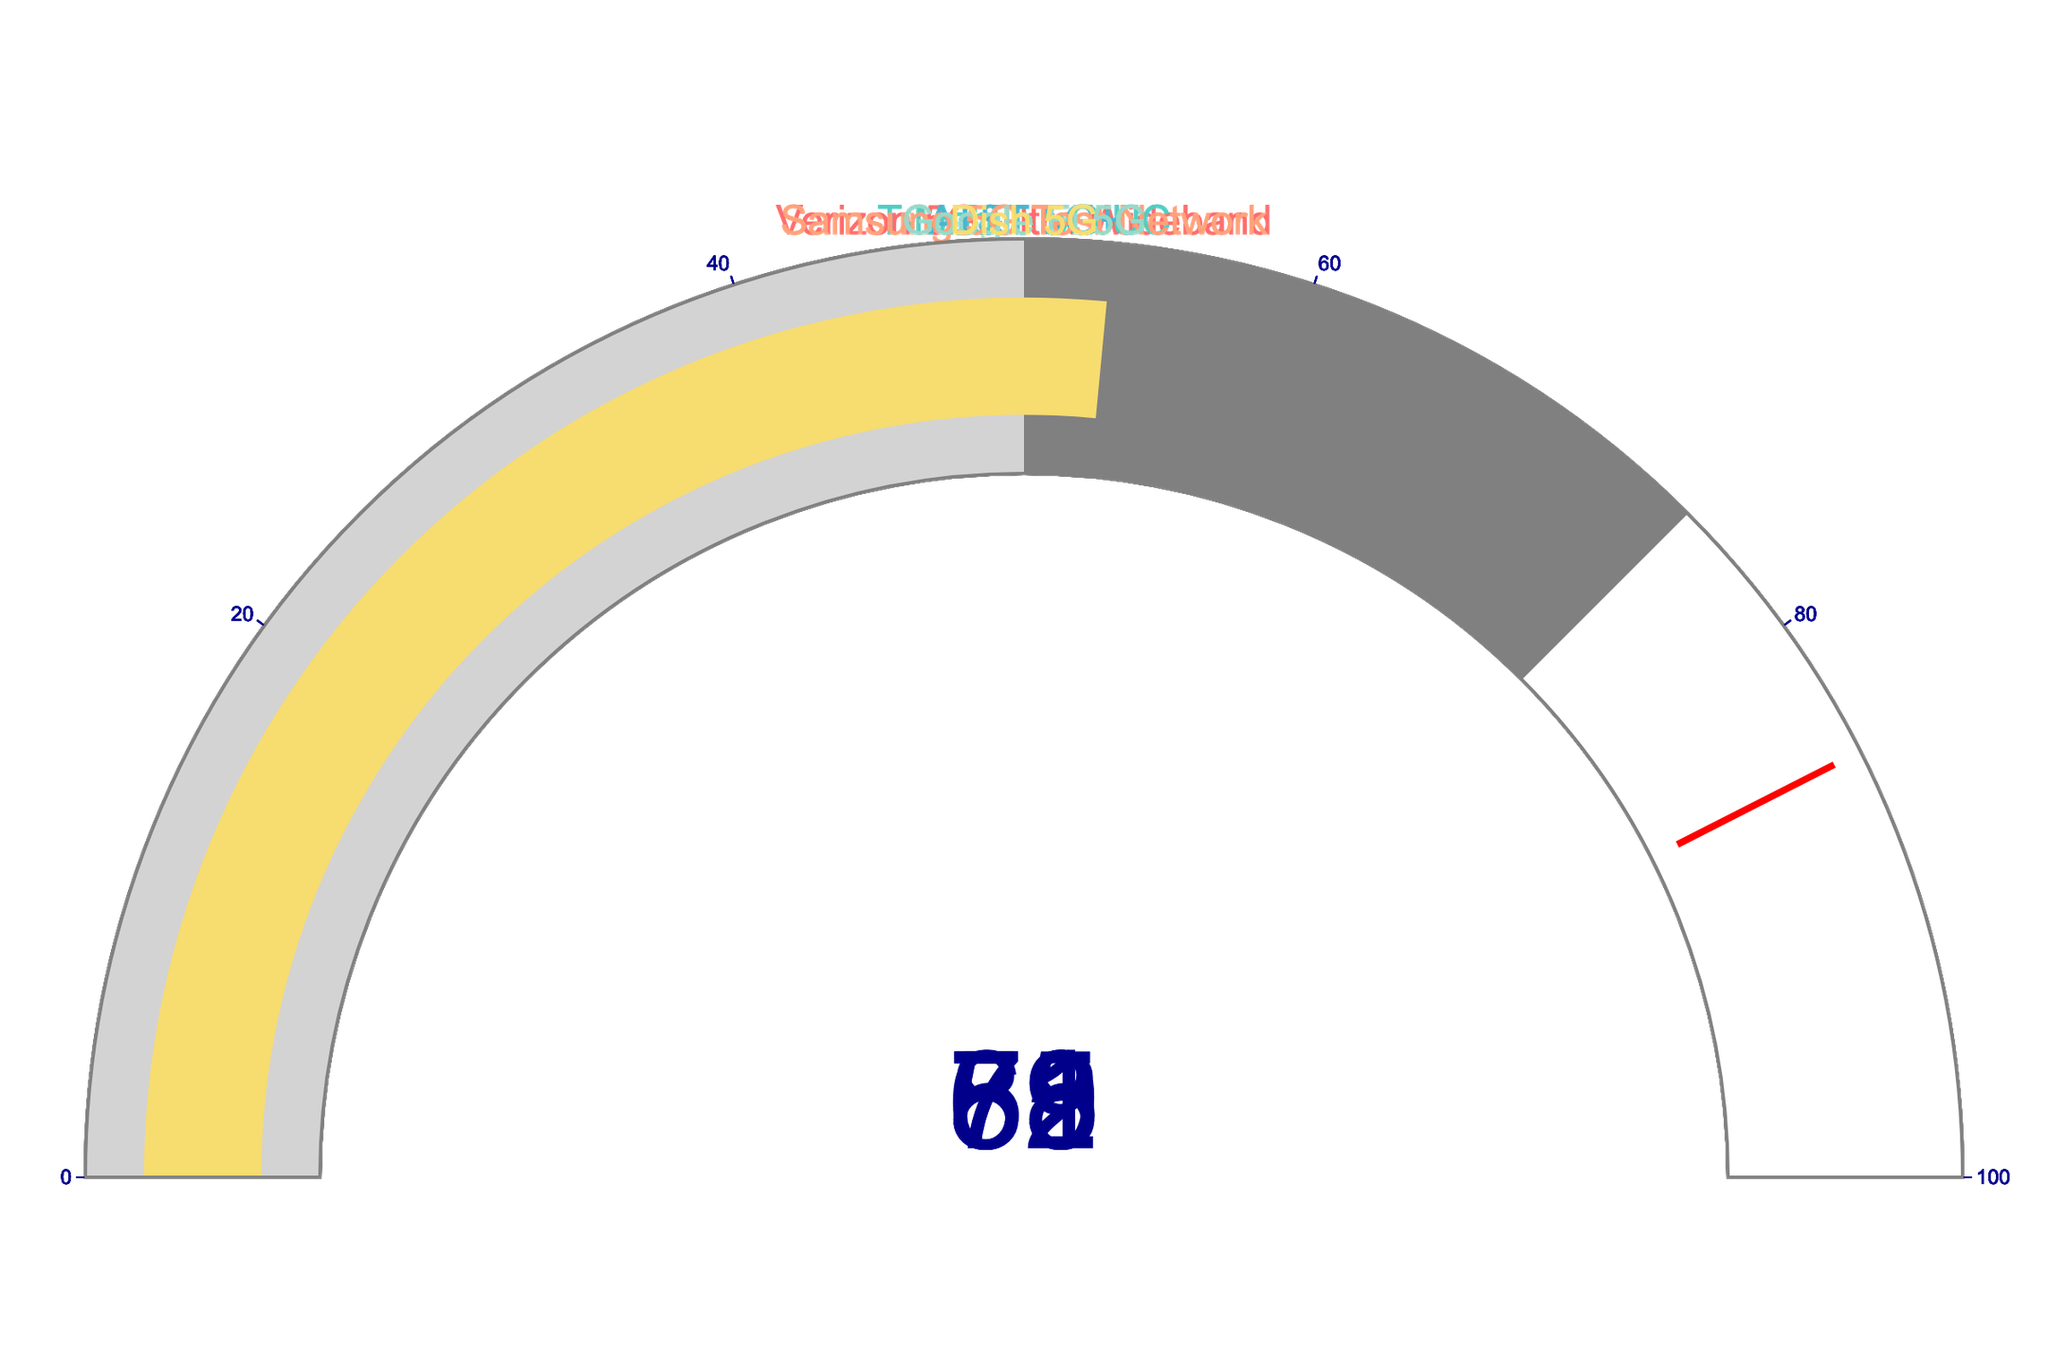Which network achieved the highest download speed percentage? Look at the gauge chart to find the network with the highest percentage value. Samsung 5G Test Network has 82%, which is the highest among the listed networks.
Answer: Samsung 5G Test Network Which network had the lowest download speed percentage? Identify the gauge with the lowest percentage value. Dish 5G has a percentage of 53%, which is the lowest.
Answer: Dish 5G How does the download speed percentage of AT&T 5G+ compare to T-Mobile 5G UC? Compare the percentage values on the gauge charts for both networks. AT&T 5G+ shows 71% and T-Mobile 5G UC shows 65%. 71% is greater than 65%.
Answer: Higher What is the average download speed percentage of all networks? Sum up the percentage values and divide by the number of networks. (78 + 65 + 71 + 82 + 59 + 53) / 6 = 68
Answer: 68 How many networks achieved a download speed percentage of 70% or more? Count the gauge charts with a percentage value of 70 or above. Verizon 5G Ultra Wideband, AT&T 5G+, and Samsung 5G Test Network meet this criterion.
Answer: 3 Which network's gauge has the color a slightly different color (light gray) for its lowest range? Look at the gauge chart color distribution for each network. All the gauges have a range [0, 50] that is light gray, but with different primary colors indicating the network.
Answer: All networks If you ranked the networks by download speed percentage, which position would Google Fi 5G be in? Order the networks by their percentage values from highest to lowest: Samsung 5G Test Network (82), Verizon 5G Ultra Wideband (78), AT&T 5G+ (71), T-Mobile 5G UC (65), Google Fi 5G (59), Dish 5G (53). Google Fi 5G is 5th.
Answer: 5th By what percent does the Samsung 5G Test Network exceed the average download speed percentage of all networks? First, find the average percentage, which is 68. Samsung 5G Test Network has 82%, the difference is 82 - 68 = 14%.
Answer: 14% Which networks fall into the 'good' range defined by the color gray (between 50 and 75%)? Assess which networks have percentage values between 50 and 75%. Verizon 5G Ultra Wideband (78) is above, AT&T 5G+ (71), and T-Mobile 5G UC (65) are in the range.
Answer: AT&T 5G+, T-Mobile 5G UC What is the total sum of the download speed percentages for Verizon 5G Ultra Wideband and AT&T 5G+? Add the percentage values of both networks. Verizon 5G Ultra Wideband (78%) + AT&T 5G+ (71%) = 149%
Answer: 149% 